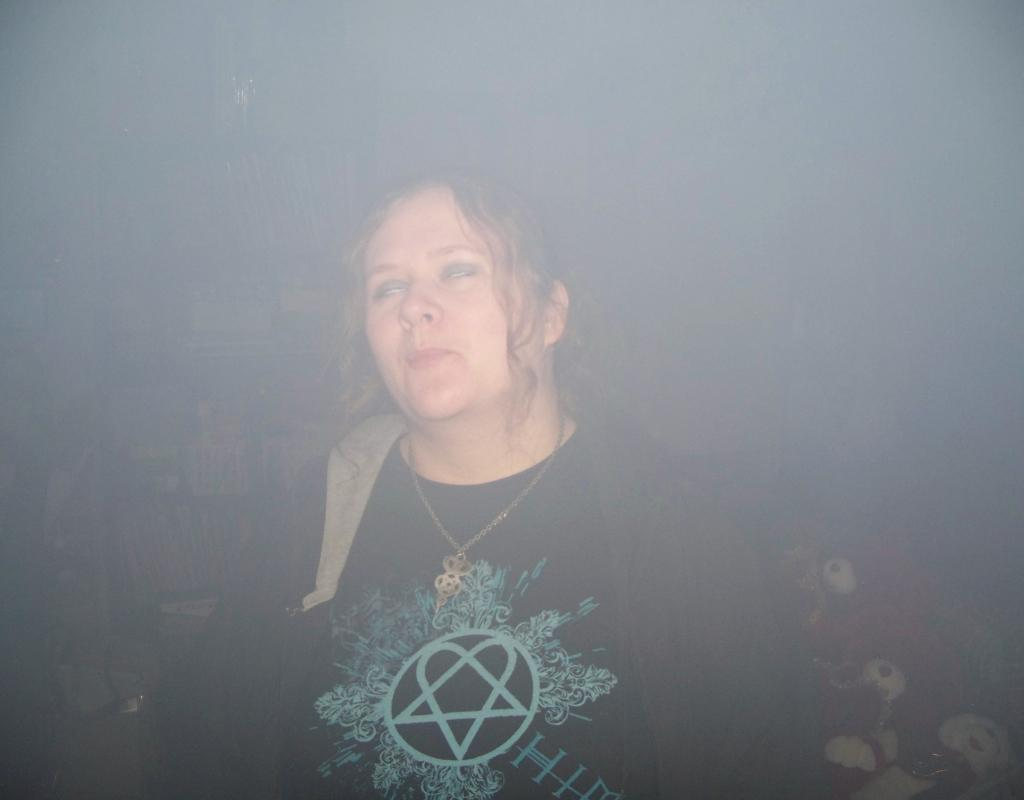What is the main subject of the image? There is a woman in the image. Can you describe anything else in the image besides the woman? There is a soft toy behind the woman. What type of bomb can be seen in the image? There is no bomb present in the image. Is there a river visible in the image? There is no river present in the image. 